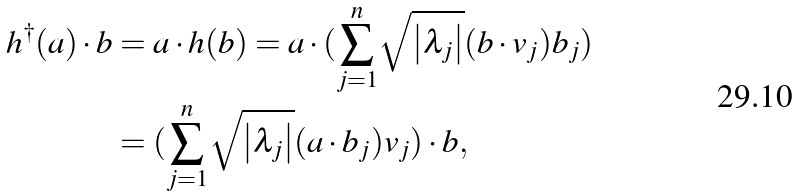<formula> <loc_0><loc_0><loc_500><loc_500>h ^ { \dagger } ( a ) \cdot b & = a \cdot h ( b ) = a \cdot ( \overset { n } { \underset { j = 1 } { \sum } } \sqrt { \left | \lambda _ { j } \right | } ( b \cdot v _ { j } ) b _ { j } ) \\ & = ( \overset { n } { \underset { j = 1 } { \sum } } \sqrt { \left | \lambda _ { j } \right | } ( a \cdot b _ { j } ) v _ { j } ) \cdot b ,</formula> 